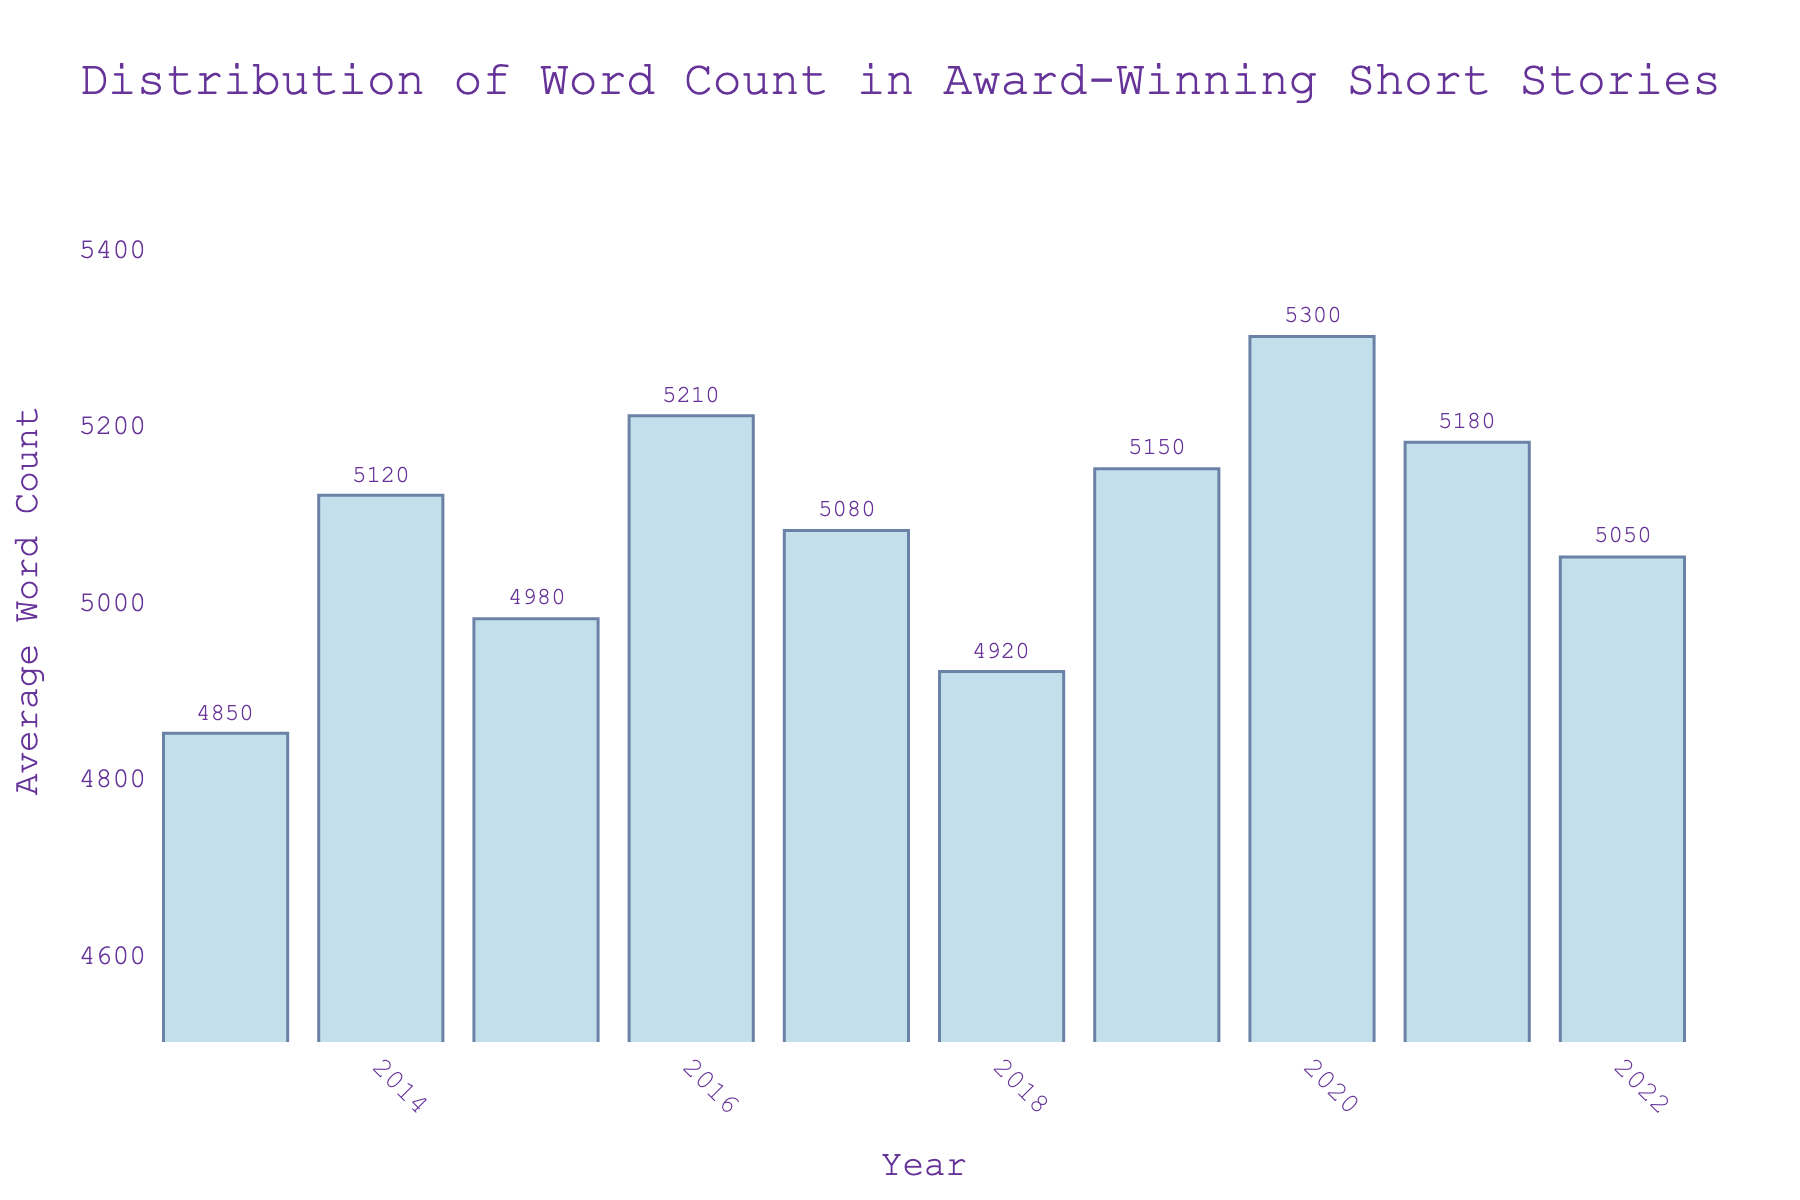Which year had the highest average word count? By looking at the height of the bars on the chart, identify the tallest one. The bar corresponding to 2020 is the highest, indicating it had the highest average word count.
Answer: 2020 What is the average word count for the year 2018? Refer to the annotated figure and find the annotation for the year 2018. The annotation shows the value 4920.
Answer: 4920 Is the average word count in 2021 higher or lower than in 2014? Compare the heights of the bars for the years 2021 and 2014. The bar for 2021 is slightly higher than the bar for 2014.
Answer: Higher What is the trend in average word count from 2018 to 2020? Observe the heights of the bars for the years 2018, 2019, and 2020. The bars show an increasing trend: 2018 < 2019 < 2020.
Answer: Increasing What was the difference between the average word counts in 2013 and 2020? Look at the annotations for 2013 and 2020. Subtract the value for 2013 (4850) from the value for 2020 (5300). Thus, the difference is 5300 - 4850 = 450.
Answer: 450 In which year was the average word count closest to 5000? Identify the bars with values close to 5000 by looking at their annotations. The bar for 2022 is annotated as 5050, which is the closest to 5000.
Answer: 2022 Between which consecutive years did the average word count decrease the most? Look at the annotations and heights of consecutive years and calculate the differences. The biggest decrease is between 2016 (5210) and 2017 (5080), a difference of 130.
Answer: 2016 to 2017 What is the range of average word counts displayed in the chart? Identify the maximum and minimum average word counts from the annotations. The range is 5300 (2020) - 4850 (2013) = 450.
Answer: 450 What was the average word count as of 2019 compared to 2021? Compare the annotations for 2019 (5150) and 2021 (5180). The average was slightly lower in 2019.
Answer: Lower 